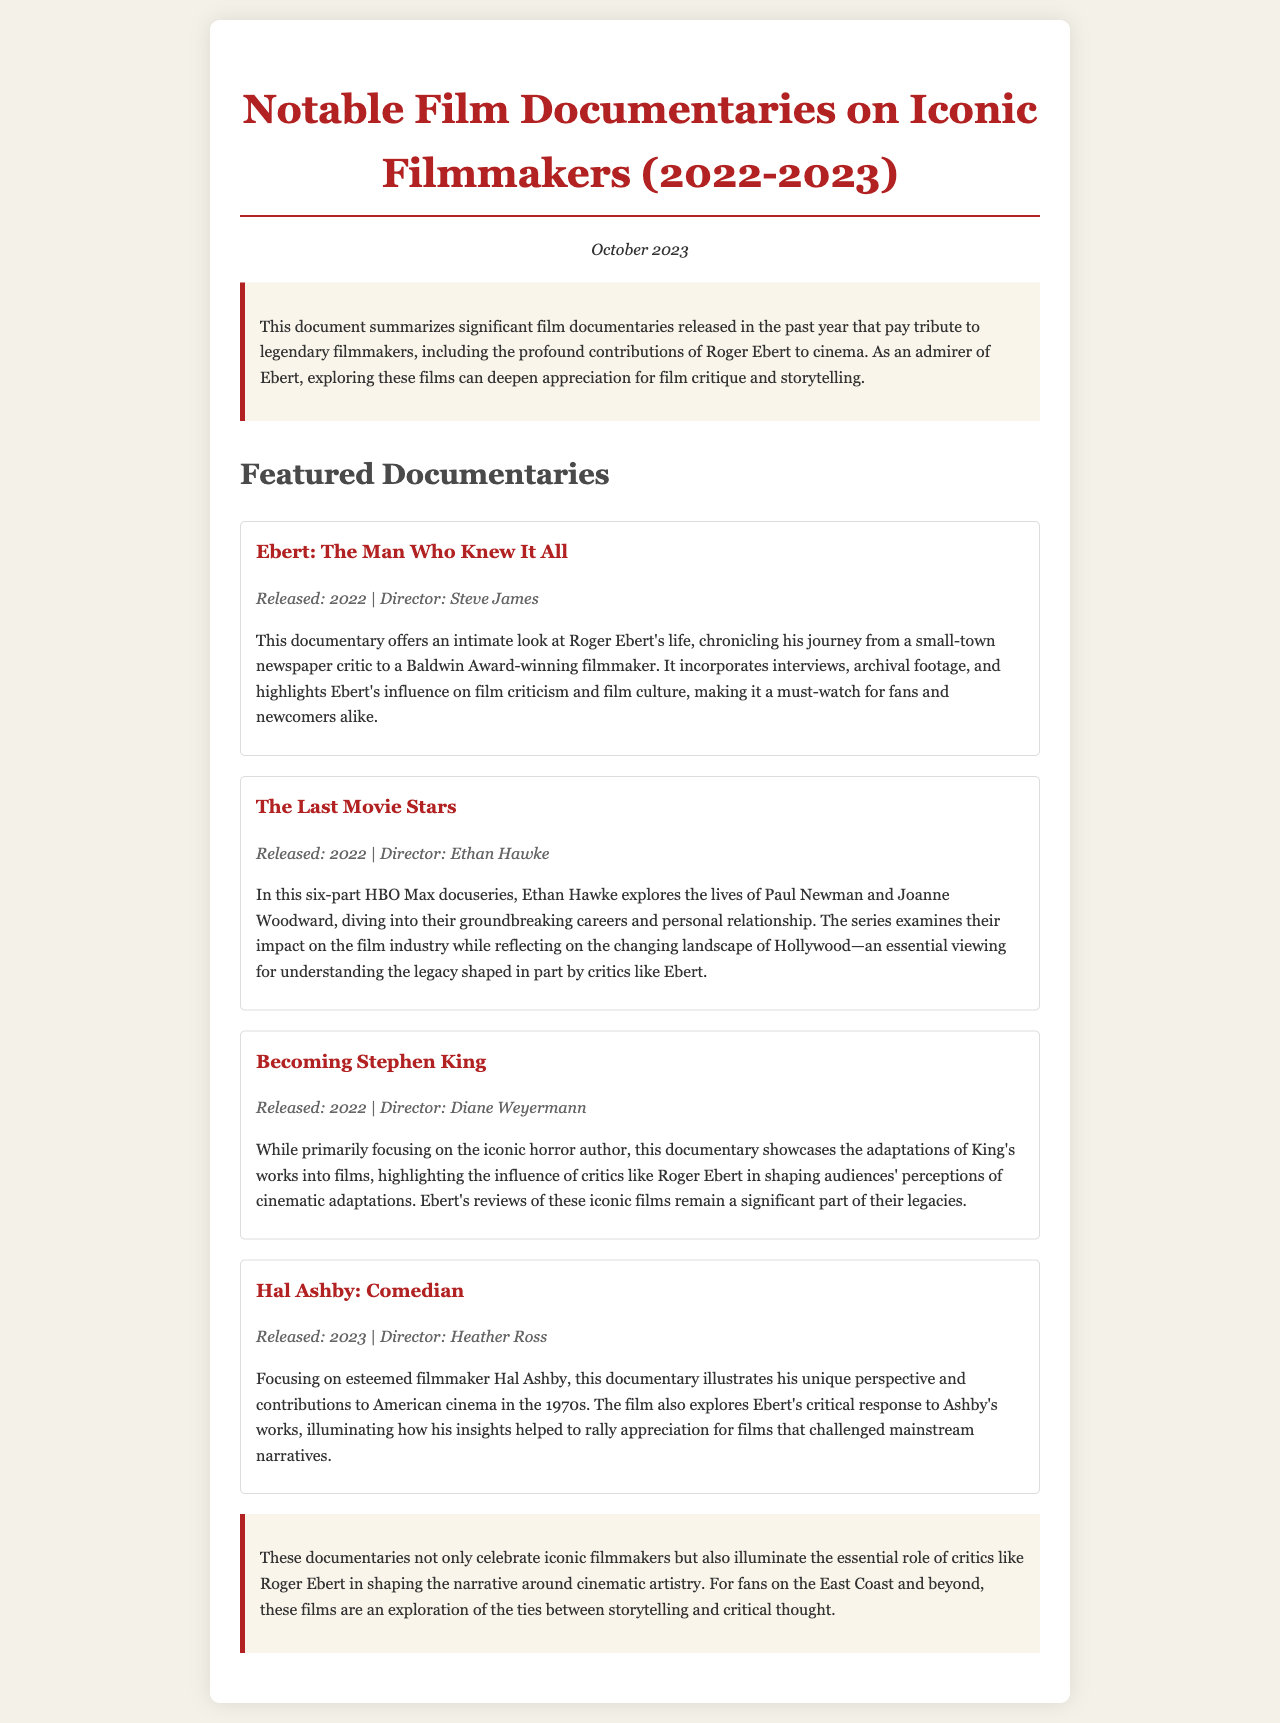What is the title of the documentary about Roger Ebert? The document specifies the title of the documentary focused on Roger Ebert as "Ebert: The Man Who Knew It All."
Answer: Ebert: The Man Who Knew It All Who directed "The Last Movie Stars"? The document lists Ethan Hawke as the director of "The Last Movie Stars."
Answer: Ethan Hawke What year was "Becoming Stephen King" released? According to the document, "Becoming Stephen King" was released in 2022.
Answer: 2022 How many documentaries are featured in the document? The document highlights a total of four notable documentaries.
Answer: Four Which filmmaker's works did Roger Ebert critically respond to in "Hal Ashby: Comedian"? The document states that the film focuses on Hal Ashby, whose works were evaluated by Roger Ebert.
Answer: Hal Ashby What is the medium of "The Last Movie Stars"? The document mentions that "The Last Movie Stars" is an HBO Max docuseries.
Answer: HBO Max docuseries What themes are explored in "Becoming Stephen King"? The document states that it showcases adaptations of King's works into films and their perception by critics like Roger Ebert.
Answer: Adaptations of King's works into films What is a key aspect of Ebert highlighted in his documentary? The document indicates that it highlights Ebert's influence on film criticism and film culture.
Answer: Influence on film criticism and film culture 